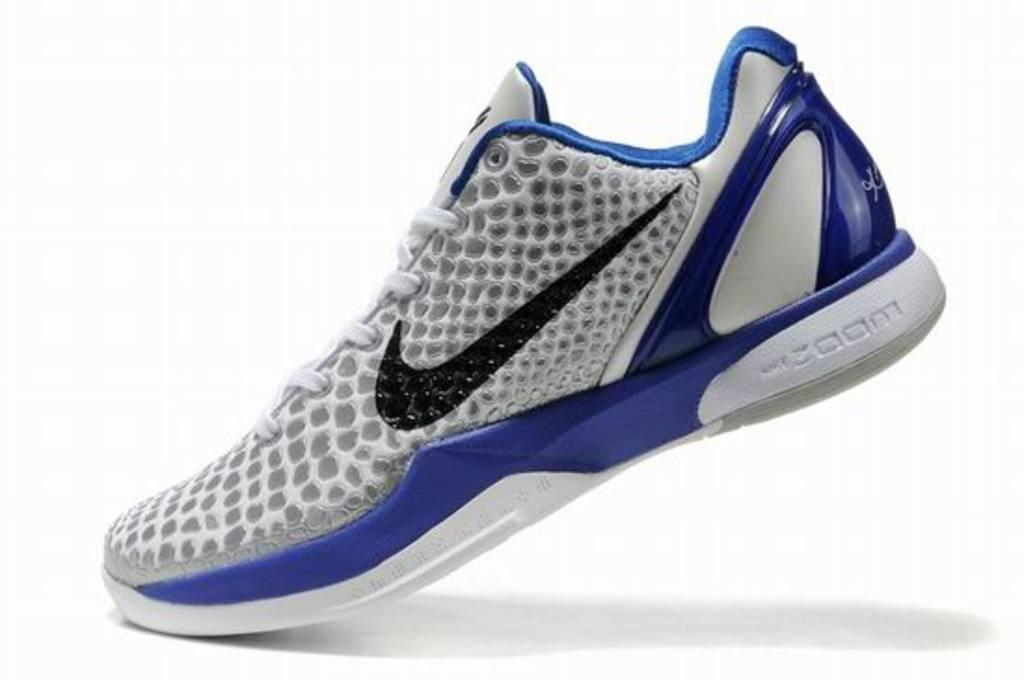What color is the shoe in the image? The shoe in the image is white and blue. What is the shoe placed on in the image? The shoe is on a white surface. What color is the background of the image? The background of the image is white. What type of boundary is visible in the image? There is no boundary visible in the image; it only features a shoe on a white surface with a white background. 